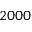<formula> <loc_0><loc_0><loc_500><loc_500>2 0 0 0</formula> 